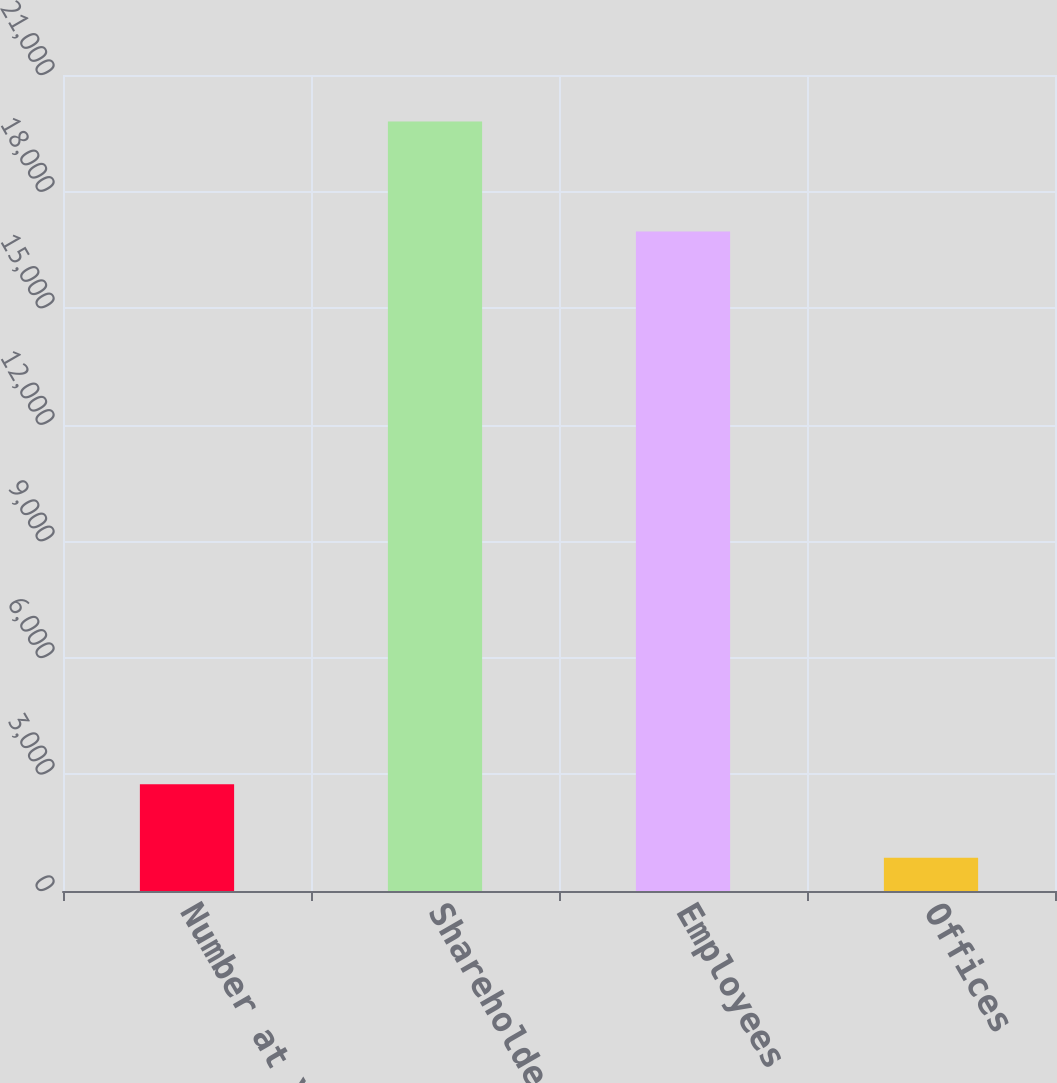Convert chart to OTSL. <chart><loc_0><loc_0><loc_500><loc_500><bar_chart><fcel>Number at Year-End<fcel>Shareholders<fcel>Employees<fcel>Offices<nl><fcel>2749.7<fcel>19802<fcel>16973<fcel>855<nl></chart> 